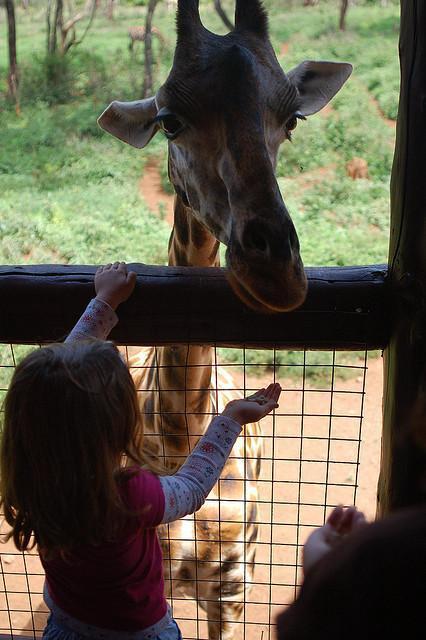How many people are in the photo?
Give a very brief answer. 2. 